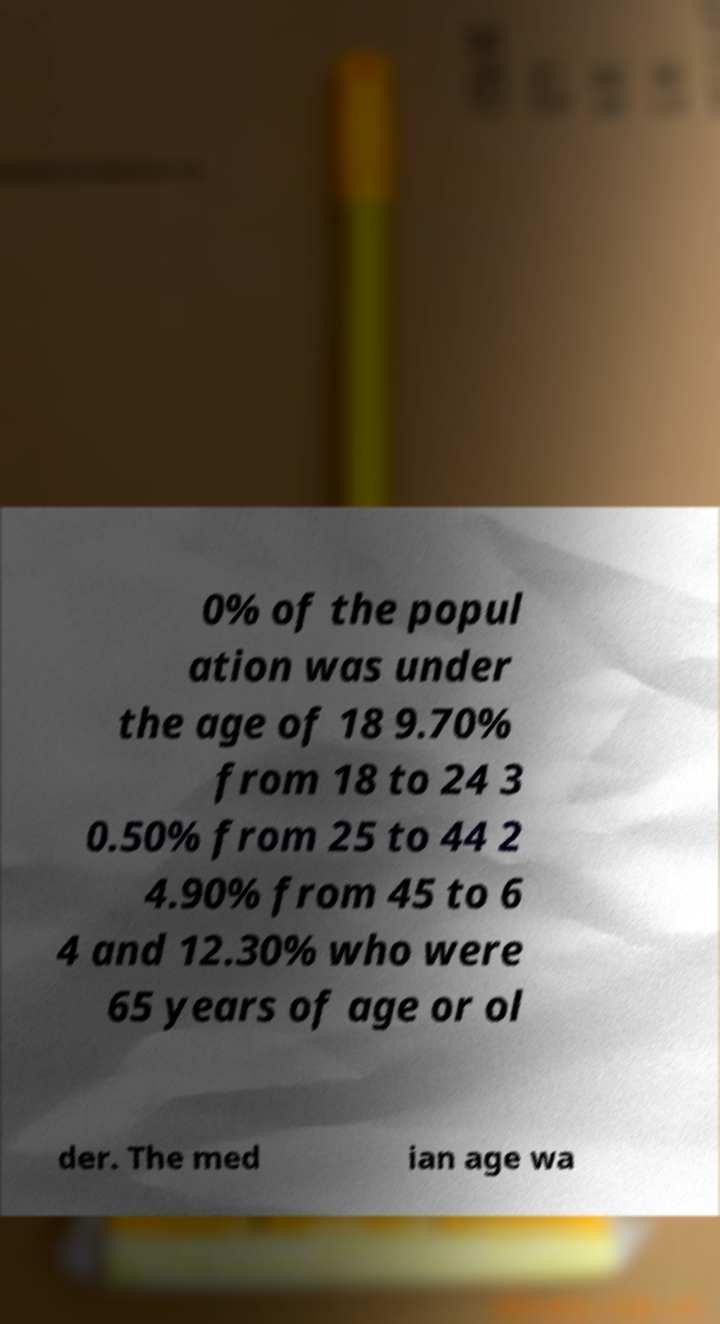For documentation purposes, I need the text within this image transcribed. Could you provide that? 0% of the popul ation was under the age of 18 9.70% from 18 to 24 3 0.50% from 25 to 44 2 4.90% from 45 to 6 4 and 12.30% who were 65 years of age or ol der. The med ian age wa 